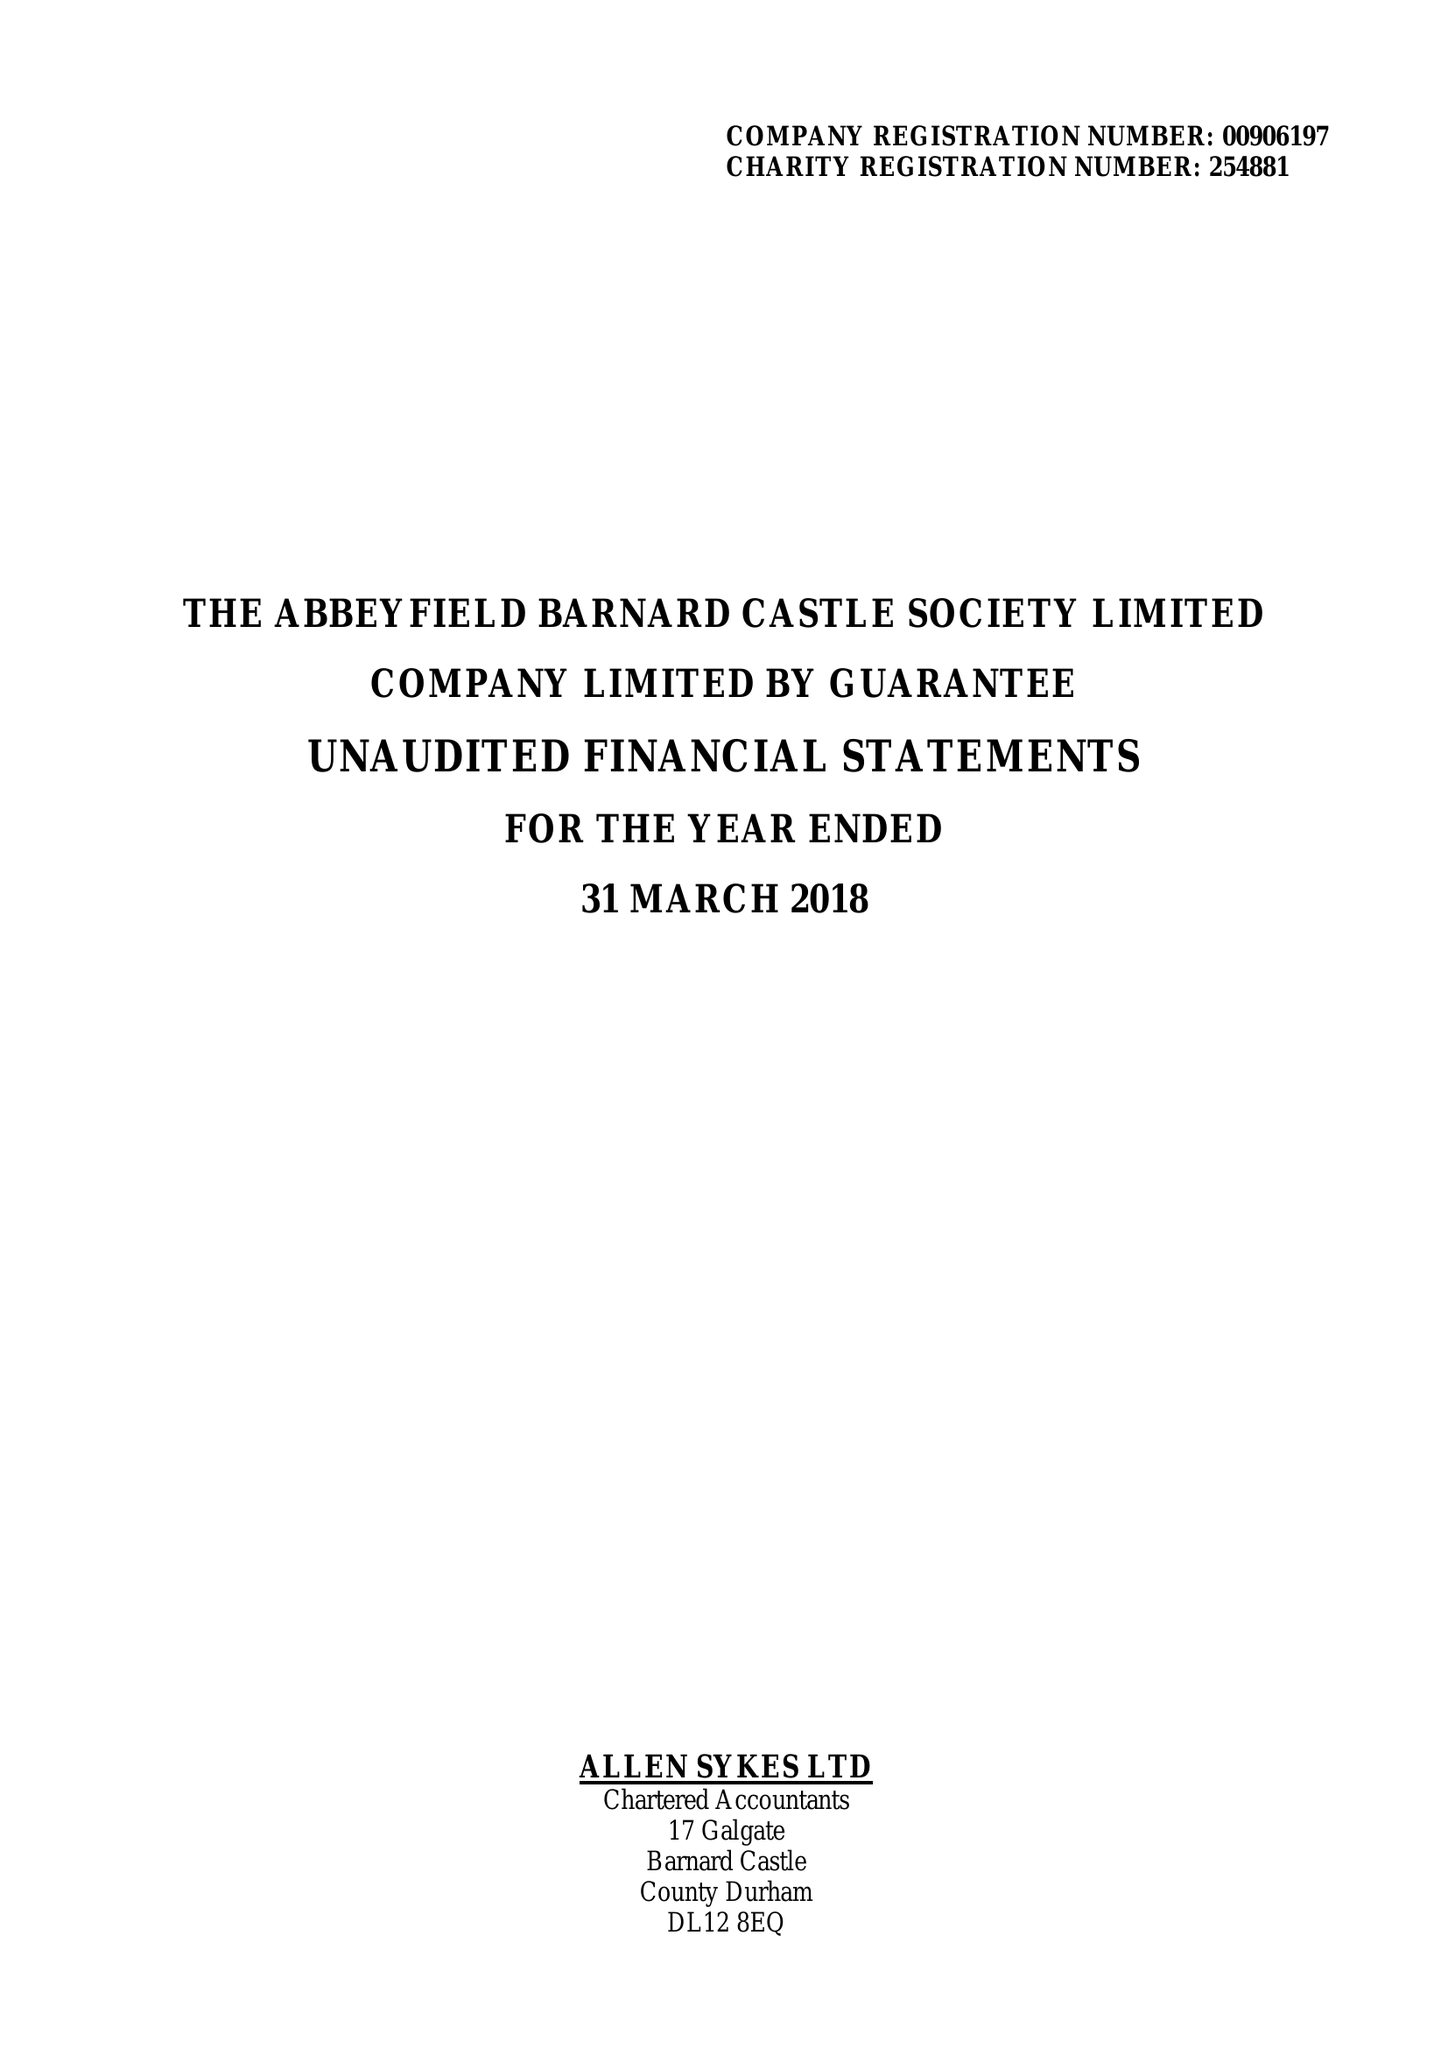What is the value for the address__post_town?
Answer the question using a single word or phrase. BARNARD CASTLE 